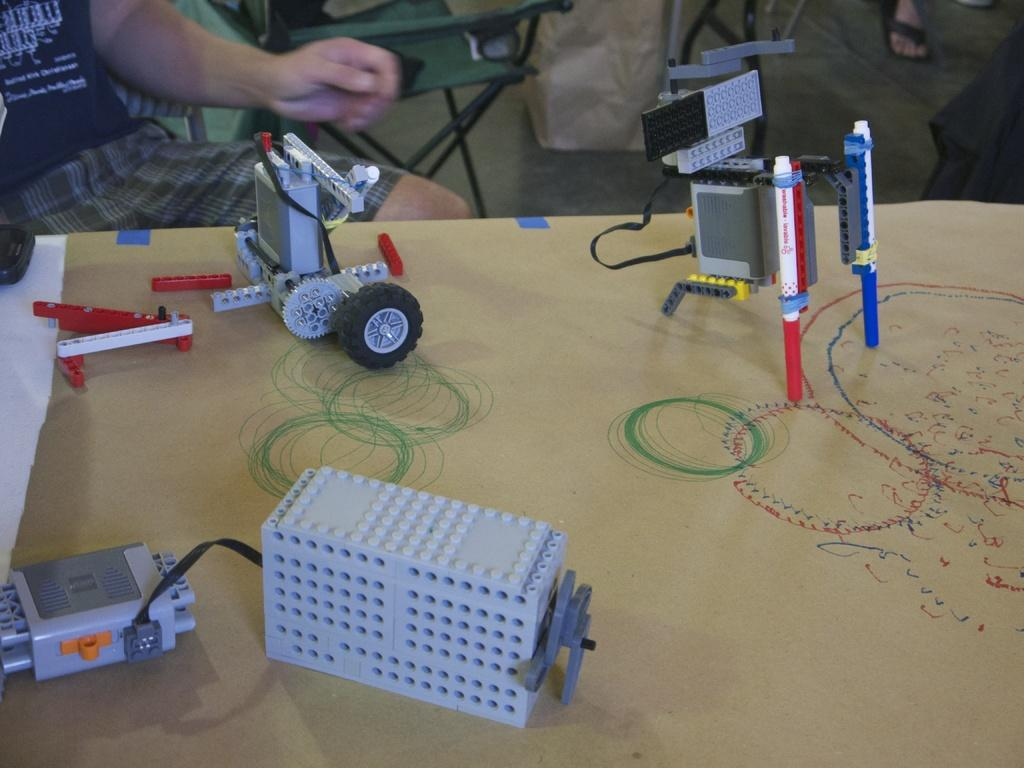What type of objects are featured in the image? There are electronic circuits in the image. What is the surface on which the electronic circuits are placed? The electronic circuits are on a wooden surface. Are there any human elements in the image? Yes, human hands are visible in the image. How many dolls are present on the wooden surface in the image? There are no dolls present in the image; it features electronic circuits and human hands. Can you describe the movement of the minute hand in the image? There is no clock or minute hand present in the image. 